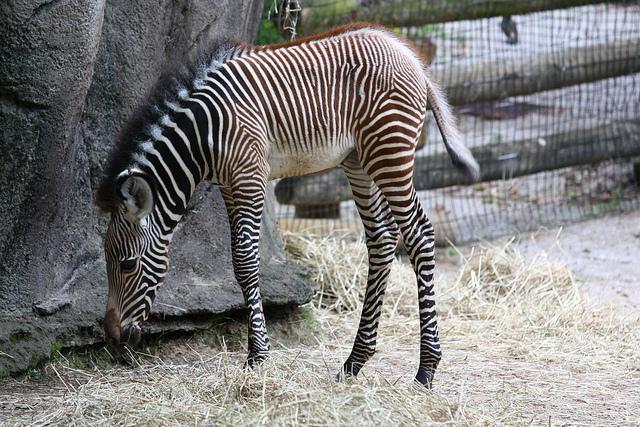How many skateboards are visible in the image?
Give a very brief answer. 0. 